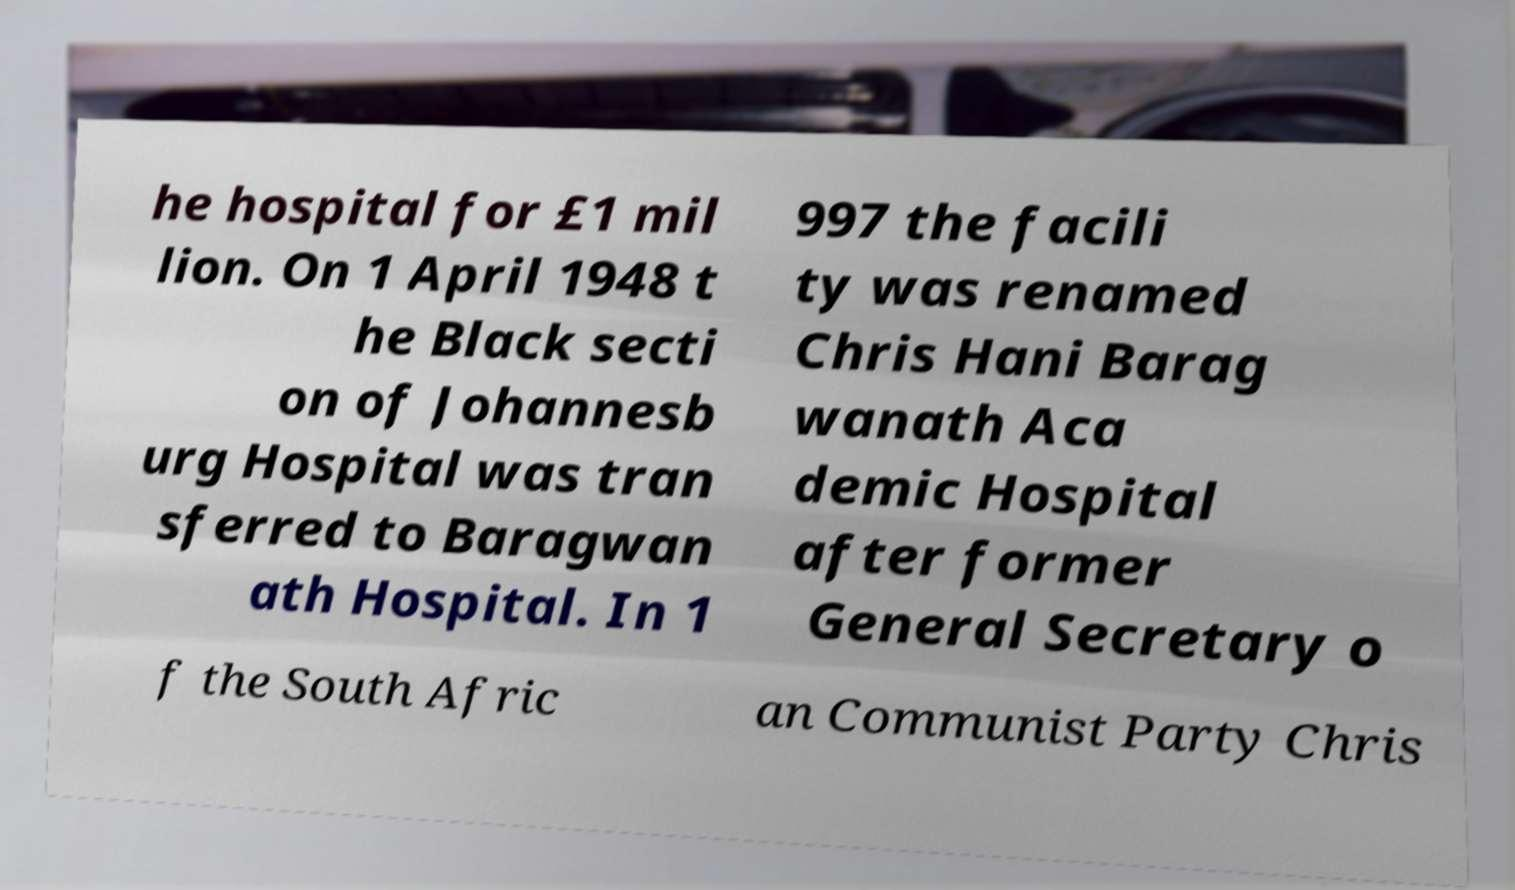Please read and relay the text visible in this image. What does it say? he hospital for £1 mil lion. On 1 April 1948 t he Black secti on of Johannesb urg Hospital was tran sferred to Baragwan ath Hospital. In 1 997 the facili ty was renamed Chris Hani Barag wanath Aca demic Hospital after former General Secretary o f the South Afric an Communist Party Chris 